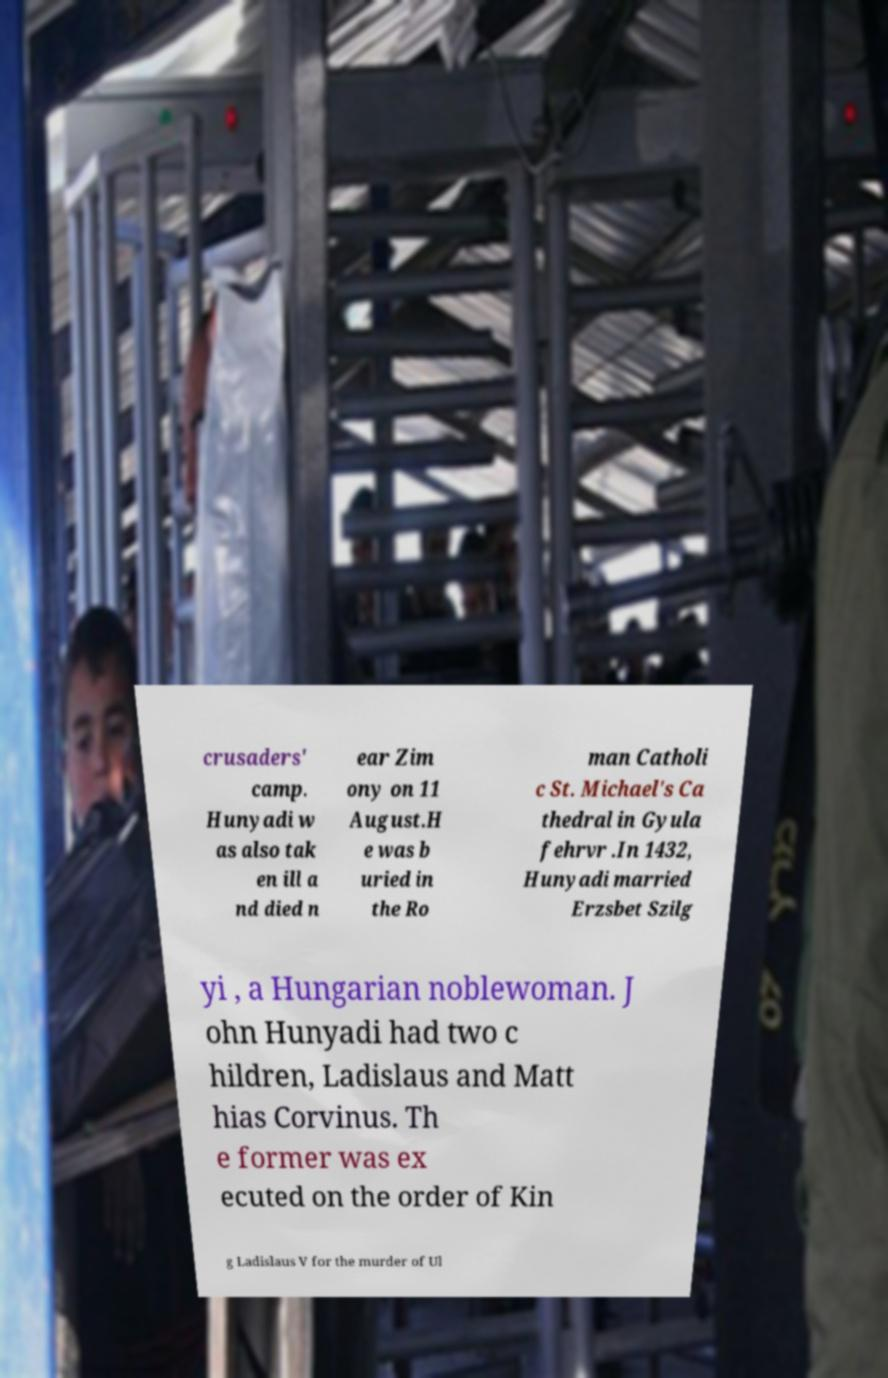Please identify and transcribe the text found in this image. crusaders' camp. Hunyadi w as also tak en ill a nd died n ear Zim ony on 11 August.H e was b uried in the Ro man Catholi c St. Michael's Ca thedral in Gyula fehrvr .In 1432, Hunyadi married Erzsbet Szilg yi , a Hungarian noblewoman. J ohn Hunyadi had two c hildren, Ladislaus and Matt hias Corvinus. Th e former was ex ecuted on the order of Kin g Ladislaus V for the murder of Ul 